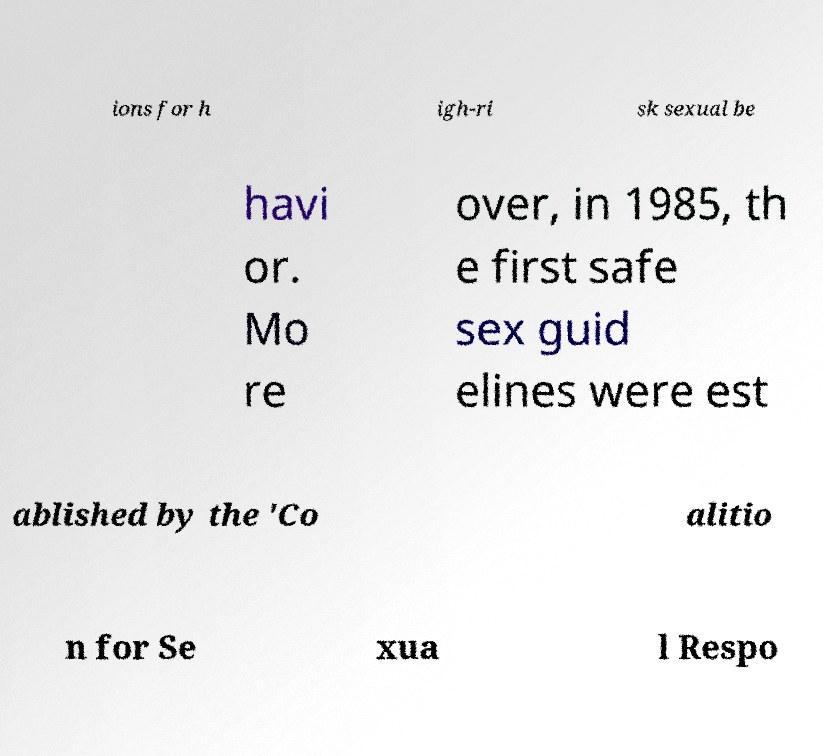For documentation purposes, I need the text within this image transcribed. Could you provide that? ions for h igh-ri sk sexual be havi or. Mo re over, in 1985, th e first safe sex guid elines were est ablished by the 'Co alitio n for Se xua l Respo 